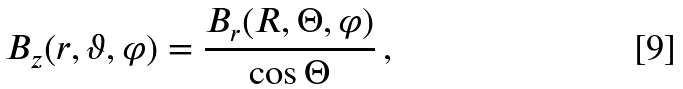<formula> <loc_0><loc_0><loc_500><loc_500>B _ { z } ( r , \vartheta , \varphi ) = \frac { B _ { r } ( R , \Theta , \varphi ) } { \cos \Theta } \, ,</formula> 